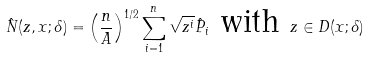<formula> <loc_0><loc_0><loc_500><loc_500>\hat { N } ( z , x ; \delta ) = \left ( \frac { n } { A } \right ) ^ { 1 / 2 } \sum _ { i = 1 } ^ { n } \sqrt { z ^ { i } } \hat { P } _ { i } \text { with } z \in D ( x ; \delta )</formula> 